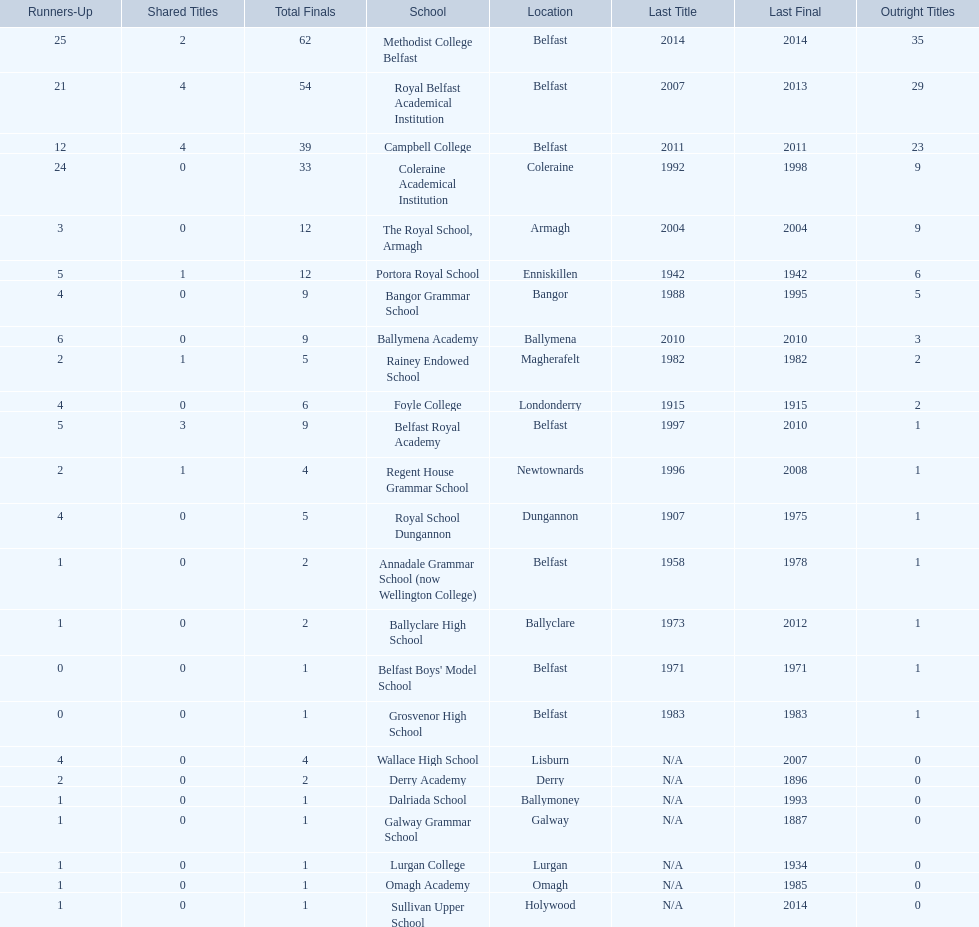How many outright titles does coleraine academical institution have? 9. What other school has this amount of outright titles The Royal School, Armagh. 